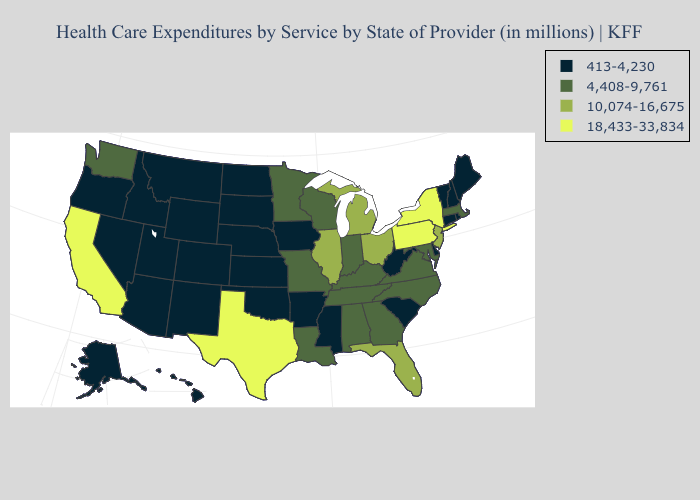Is the legend a continuous bar?
Short answer required. No. Which states have the lowest value in the Northeast?
Short answer required. Connecticut, Maine, New Hampshire, Rhode Island, Vermont. What is the lowest value in the South?
Short answer required. 413-4,230. Name the states that have a value in the range 18,433-33,834?
Short answer required. California, New York, Pennsylvania, Texas. How many symbols are there in the legend?
Answer briefly. 4. What is the lowest value in the MidWest?
Concise answer only. 413-4,230. Does Maine have the same value as Minnesota?
Write a very short answer. No. Which states have the lowest value in the USA?
Short answer required. Alaska, Arizona, Arkansas, Colorado, Connecticut, Delaware, Hawaii, Idaho, Iowa, Kansas, Maine, Mississippi, Montana, Nebraska, Nevada, New Hampshire, New Mexico, North Dakota, Oklahoma, Oregon, Rhode Island, South Carolina, South Dakota, Utah, Vermont, West Virginia, Wyoming. Which states have the lowest value in the MidWest?
Concise answer only. Iowa, Kansas, Nebraska, North Dakota, South Dakota. What is the value of North Carolina?
Keep it brief. 4,408-9,761. Among the states that border Delaware , which have the lowest value?
Write a very short answer. Maryland. Among the states that border Nevada , does California have the lowest value?
Short answer required. No. Which states hav the highest value in the South?
Quick response, please. Texas. What is the value of South Carolina?
Quick response, please. 413-4,230. 